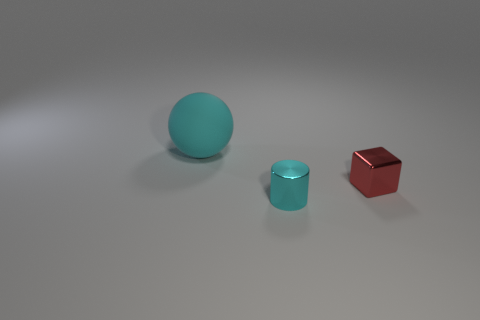There is a cyan object behind the cyan cylinder; what material is it?
Make the answer very short. Rubber. Is the shape of the big cyan thing the same as the small metallic thing behind the tiny cyan metallic cylinder?
Ensure brevity in your answer.  No. What number of small shiny blocks are behind the cyan thing behind the tiny metallic object behind the cyan cylinder?
Ensure brevity in your answer.  0. Are there any other things that have the same shape as the big matte object?
Make the answer very short. No. How many cylinders are red metallic things or large cyan things?
Your response must be concise. 0. The tiny cyan thing is what shape?
Provide a short and direct response. Cylinder. Are there any tiny red metal objects in front of the cube?
Your response must be concise. No. Do the small red cube and the cyan thing that is behind the cylinder have the same material?
Provide a succinct answer. No. Do the cyan thing in front of the tiny cube and the red object have the same shape?
Offer a terse response. No. How many cylinders are the same material as the block?
Provide a short and direct response. 1. 